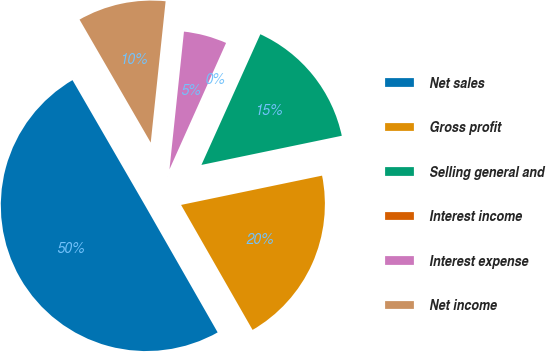Convert chart to OTSL. <chart><loc_0><loc_0><loc_500><loc_500><pie_chart><fcel>Net sales<fcel>Gross profit<fcel>Selling general and<fcel>Interest income<fcel>Interest expense<fcel>Net income<nl><fcel>49.92%<fcel>19.99%<fcel>15.0%<fcel>0.04%<fcel>5.03%<fcel>10.02%<nl></chart> 